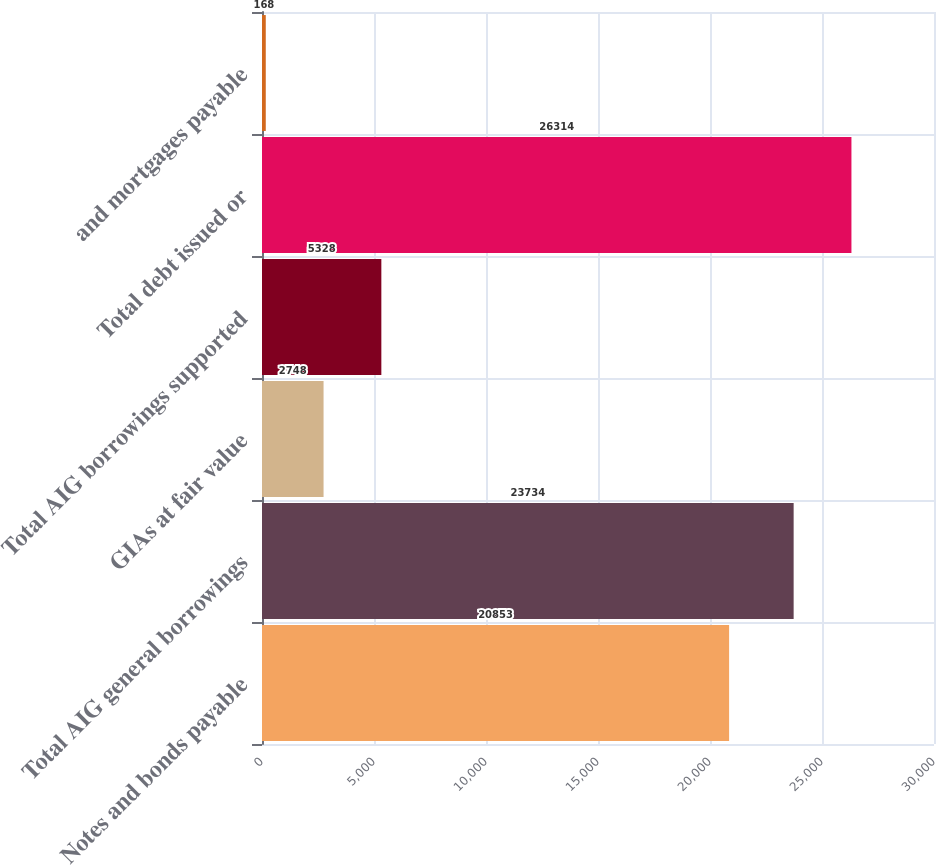Convert chart to OTSL. <chart><loc_0><loc_0><loc_500><loc_500><bar_chart><fcel>Notes and bonds payable<fcel>Total AIG general borrowings<fcel>GIAs at fair value<fcel>Total AIG borrowings supported<fcel>Total debt issued or<fcel>and mortgages payable<nl><fcel>20853<fcel>23734<fcel>2748<fcel>5328<fcel>26314<fcel>168<nl></chart> 